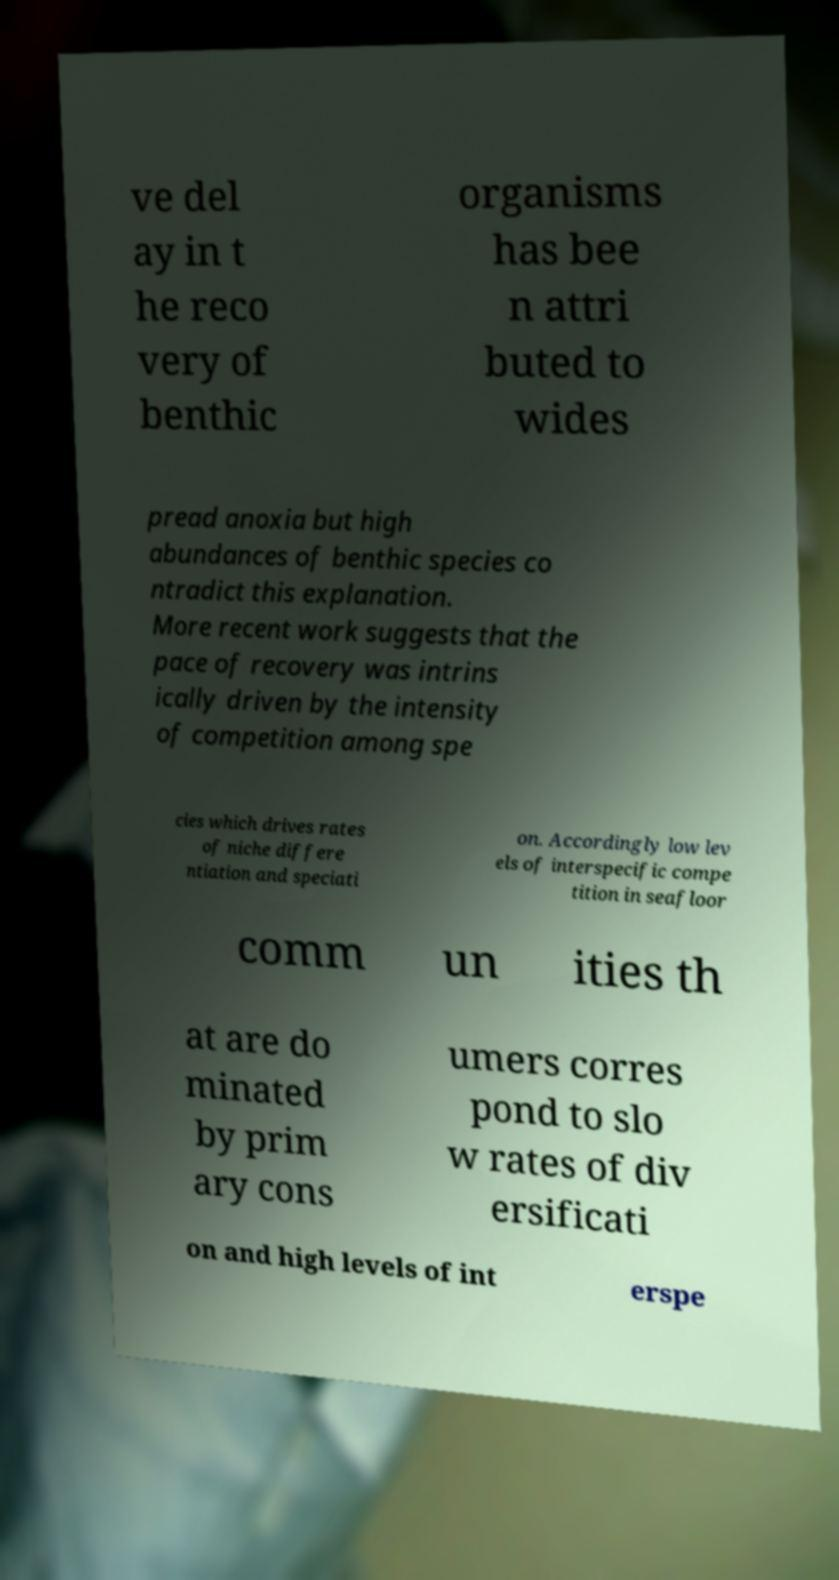Could you assist in decoding the text presented in this image and type it out clearly? ve del ay in t he reco very of benthic organisms has bee n attri buted to wides pread anoxia but high abundances of benthic species co ntradict this explanation. More recent work suggests that the pace of recovery was intrins ically driven by the intensity of competition among spe cies which drives rates of niche differe ntiation and speciati on. Accordingly low lev els of interspecific compe tition in seafloor comm un ities th at are do minated by prim ary cons umers corres pond to slo w rates of div ersificati on and high levels of int erspe 